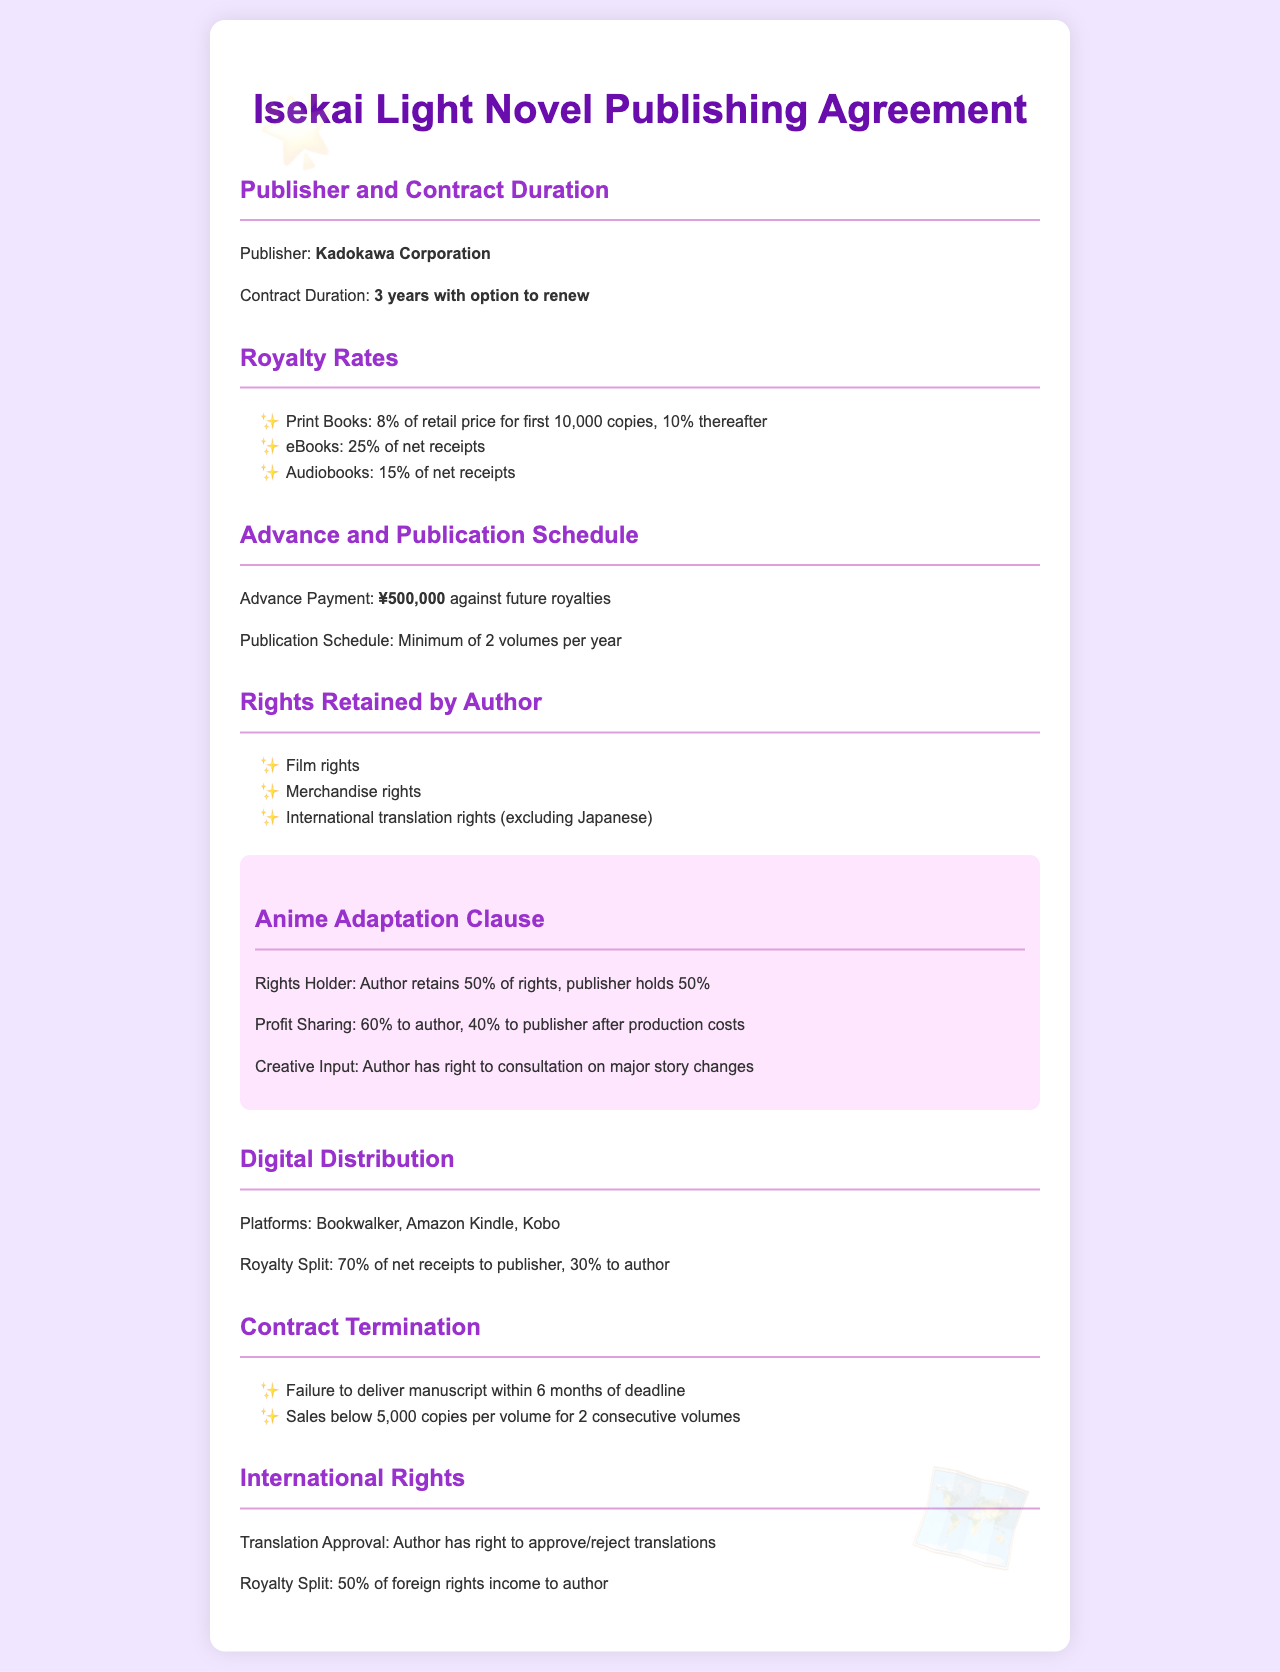What is the name of the publisher? The publisher is mentioned in the document under the section "Publisher and Contract Duration."
Answer: Kadokawa Corporation What is the contract duration? The contract duration is specified in the same section as the publisher.
Answer: 3 years with option to renew What is the advance payment amount? The advance payment is highlighted in the "Advance and Publication Schedule" section.
Answer: ¥500,000 What percentage of royalties do print books earn for the first 10,000 copies? This information can be found in the "Royalty Rates" section.
Answer: 8% What rights does the author retain? The rights retained by the author are listed under "Rights Retained by Author."
Answer: Film rights, Merchandise rights, International translation rights What is the profit sharing percentage after production costs for anime adaptations? The profit sharing percentage is stated in the "Anime Adaptation Clause."
Answer: 60% to author, 40% to publisher What platforms are mentioned for digital distribution? The platforms are mentioned in the "Digital Distribution" section.
Answer: Bookwalker, Amazon Kindle, Kobo What is the royalty split for digital distribution? The royalty split can be found in the "Digital Distribution" section.
Answer: 70% of net receipts to publisher, 30% to author What event can lead to contract termination? The events leading to contract termination are listed in the "Contract Termination" section.
Answer: Failure to deliver manuscript within 6 months of deadline 